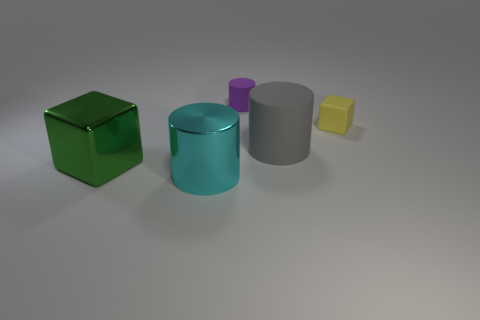Subtract all matte cylinders. How many cylinders are left? 1 Add 3 gray matte cylinders. How many objects exist? 8 Subtract all cylinders. How many objects are left? 2 Subtract 0 gray cubes. How many objects are left? 5 Subtract all yellow cylinders. Subtract all yellow cubes. How many cylinders are left? 3 Subtract all metallic blocks. Subtract all big matte objects. How many objects are left? 3 Add 1 shiny cylinders. How many shiny cylinders are left? 2 Add 2 big purple shiny cylinders. How many big purple shiny cylinders exist? 2 